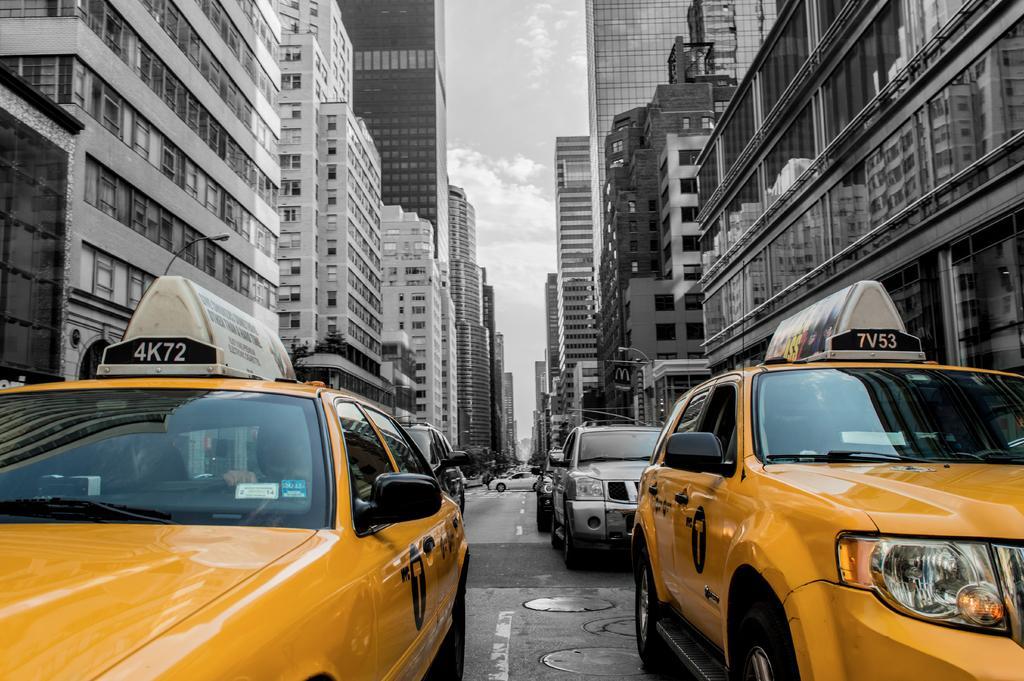In one or two sentences, can you explain what this image depicts? In the center of the image we can see cars on the road. In the background there are buildings, poles and sky. 